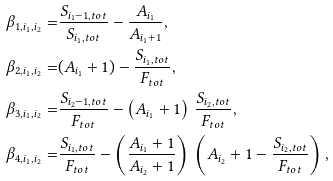Convert formula to latex. <formula><loc_0><loc_0><loc_500><loc_500>\beta _ { 1 , i _ { 1 } , i _ { 2 } } = & \frac { S _ { i _ { 1 } - 1 , t o t } } { S _ { i _ { 1 } , t o t } } - \frac { A _ { i _ { 1 } } } { A _ { i _ { 1 } + 1 } } , \\ \beta _ { 2 , i _ { 1 } , i _ { 2 } } = & ( A _ { i _ { 1 } } + 1 ) - \frac { S _ { { i _ { 1 } } , t o t } } { F _ { t o t } } , \\ \beta _ { 3 , i _ { 1 } , i _ { 2 } } = & \frac { S _ { i _ { 2 } - 1 , t o t } } { F _ { t o t } } - \left ( A _ { i _ { 1 } } + 1 \right ) \, \frac { S _ { i _ { 2 } , t o t } } { F _ { t o t } } , \\ \beta _ { 4 , i _ { 1 } , i _ { 2 } } = & \frac { S _ { { i _ { 1 } } , t o t } } { F _ { t o t } } - \left ( \frac { A _ { i _ { 1 } } + 1 } { A _ { i _ { 2 } } + 1 } \right ) \, \left ( A _ { i _ { 2 } } + 1 - \frac { S _ { { i _ { 2 } } , t o t } } { F _ { t o t } } \right ) ,</formula> 